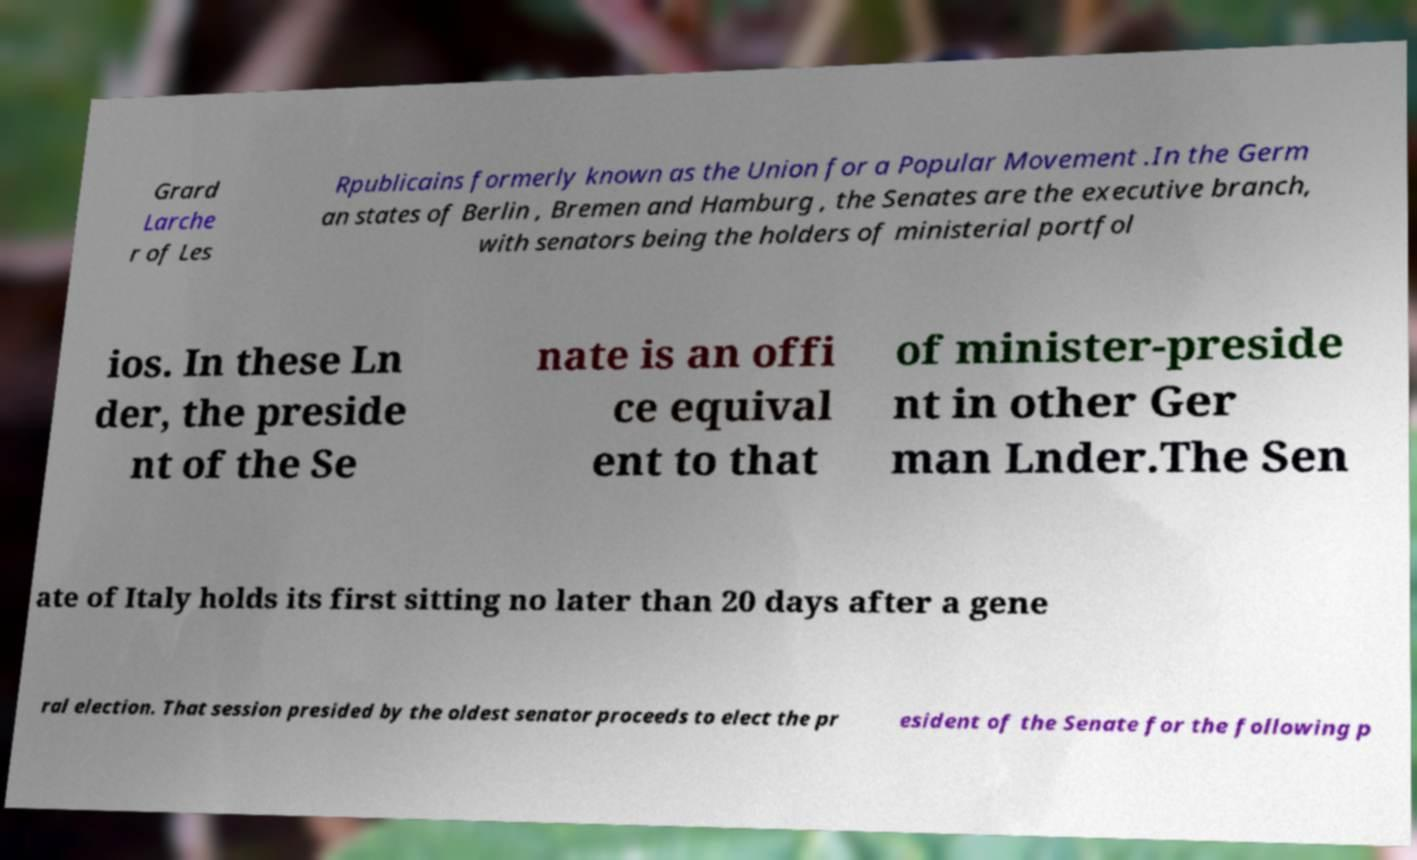Can you read and provide the text displayed in the image?This photo seems to have some interesting text. Can you extract and type it out for me? Grard Larche r of Les Rpublicains formerly known as the Union for a Popular Movement .In the Germ an states of Berlin , Bremen and Hamburg , the Senates are the executive branch, with senators being the holders of ministerial portfol ios. In these Ln der, the preside nt of the Se nate is an offi ce equival ent to that of minister-preside nt in other Ger man Lnder.The Sen ate of Italy holds its first sitting no later than 20 days after a gene ral election. That session presided by the oldest senator proceeds to elect the pr esident of the Senate for the following p 